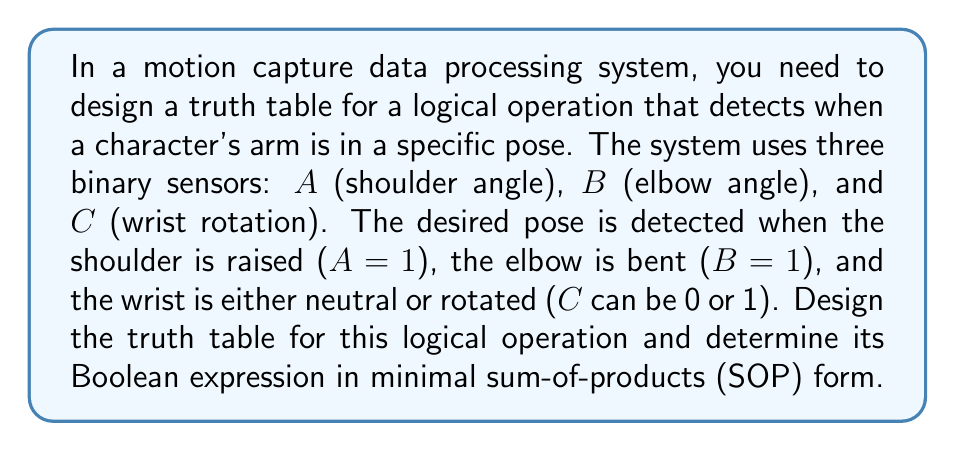Could you help me with this problem? Let's approach this step-by-step:

1) First, we need to create the truth table for all possible combinations of $A$, $B$, and $C$:

   $A$ | $B$ | $C$ | Output
   ----+-----+-----+-------
   0   | 0   | 0   | 0
   0   | 0   | 1   | 0
   0   | 1   | 0   | 0
   0   | 1   | 1   | 0
   1   | 0   | 0   | 0
   1   | 0   | 1   | 0
   1   | 1   | 0   | 1
   1   | 1   | 1   | 1

2) The output is 1 when $A=1$, $B=1$, and $C$ can be either 0 or 1.

3) To write the Boolean expression, we identify the rows where the output is 1:
   - $A=1$, $B=1$, $C=0$: $ABC'$
   - $A=1$, $B=1$, $C=1$: $ABC$

4) The sum of these terms gives us the Boolean expression:
   $F = ABC' + ABC$

5) This can be simplified using Boolean algebra:
   $F = AB(C' + C)$
   $F = AB(1)$ (since $C' + C = 1$ for any $C$)
   $F = AB$

Therefore, the minimal sum-of-products (SOP) form of the Boolean expression is $AB$.
Answer: $F = AB$ 